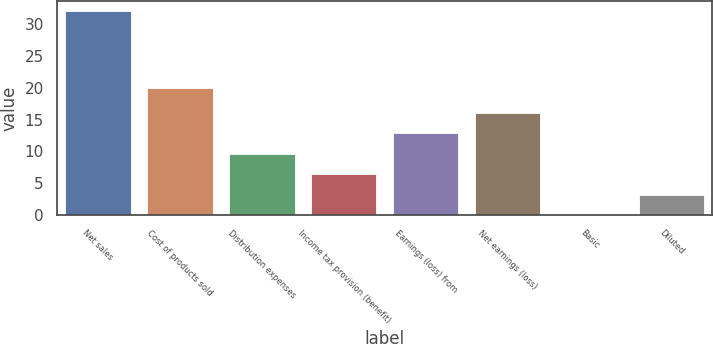<chart> <loc_0><loc_0><loc_500><loc_500><bar_chart><fcel>Net sales<fcel>Cost of products sold<fcel>Distribution expenses<fcel>Income tax provision (benefit)<fcel>Earnings (loss) from<fcel>Net earnings (loss)<fcel>Basic<fcel>Diluted<nl><fcel>32<fcel>20<fcel>9.61<fcel>6.41<fcel>12.81<fcel>16.01<fcel>0.01<fcel>3.21<nl></chart> 